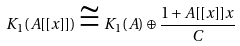Convert formula to latex. <formula><loc_0><loc_0><loc_500><loc_500>K _ { 1 } ( A [ [ x ] ] ) \cong K _ { 1 } ( A ) \oplus \frac { 1 + A [ [ x ] ] x } { C }</formula> 